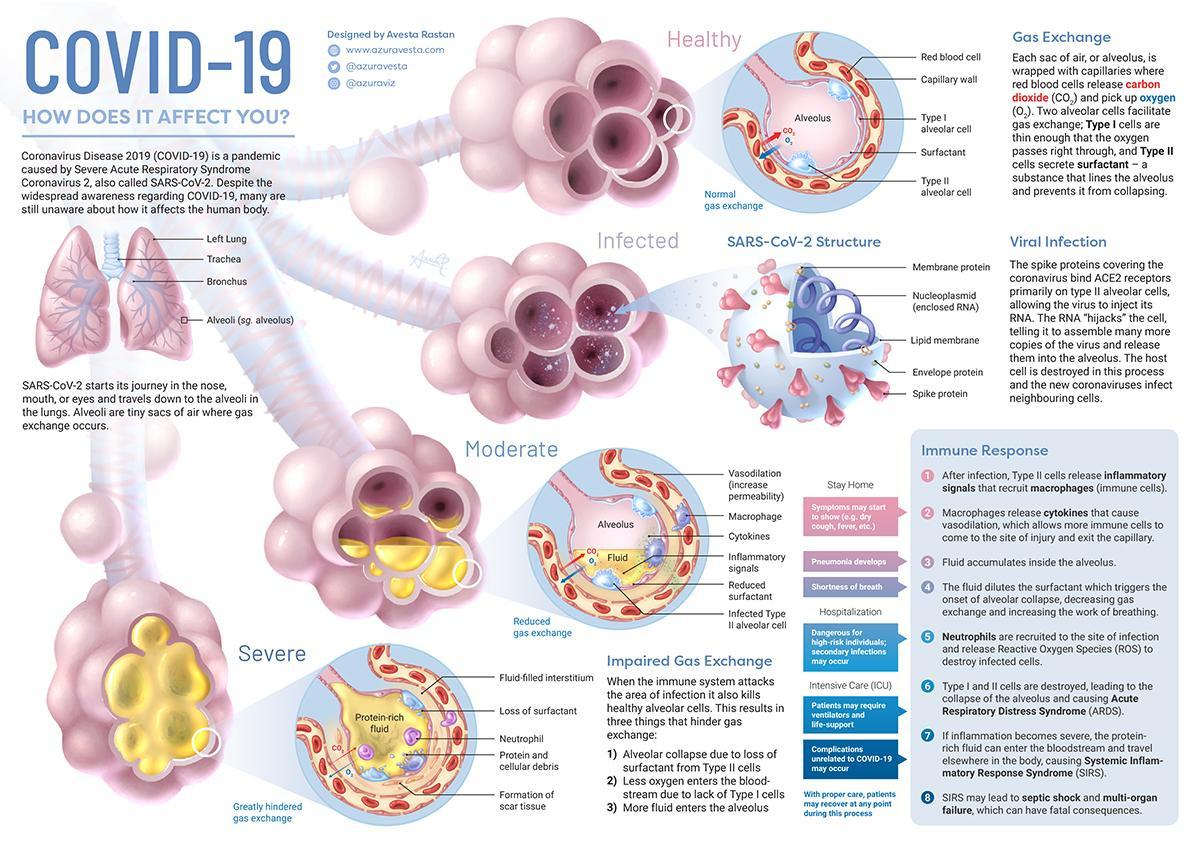What are the 2 gases shown in normal gas exchange diagram
Answer the question with a short phrase. CO2, O2 What is the full form of SARS Severe Acute Respiratory Syndrome What is the yellow fluid that completely fills the Alveolus in severe infection Protein-rich fluid What is the blue spiral tube in the SARS-CoV-2 structure Nucleoplasmid (enclosed RNA) At which stage of immune response is hospitalization required 5 What could be the requirements in an ICU Patients may require ventilators and life-support, Complications unrelated to COVID-19 may occur What gets filled in the Alveolus when infected with the virus moderately Fluid 